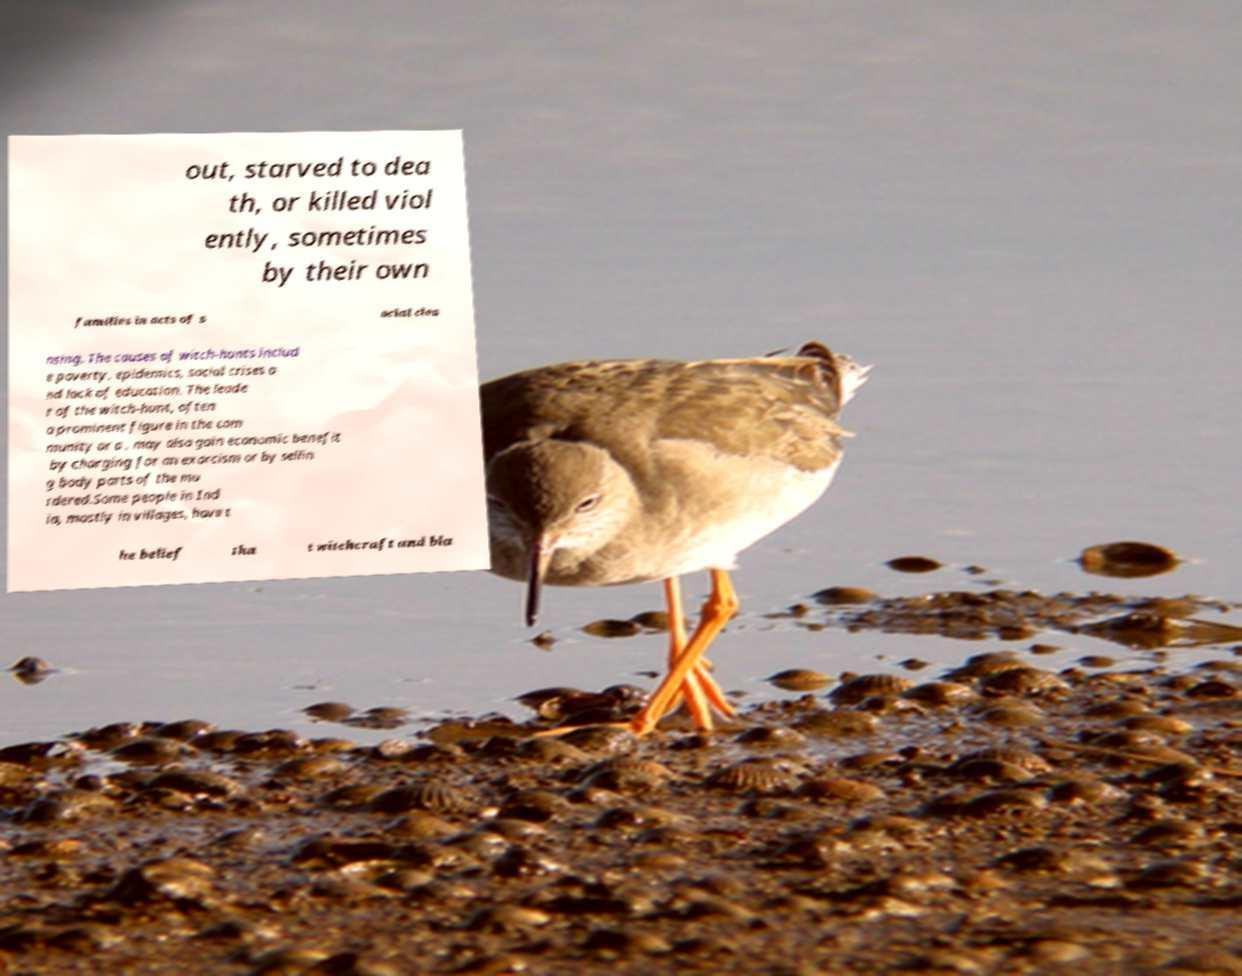Could you assist in decoding the text presented in this image and type it out clearly? out, starved to dea th, or killed viol ently, sometimes by their own families in acts of s ocial clea nsing. The causes of witch-hunts includ e poverty, epidemics, social crises a nd lack of education. The leade r of the witch-hunt, often a prominent figure in the com munity or a , may also gain economic benefit by charging for an exorcism or by sellin g body parts of the mu rdered.Some people in Ind ia, mostly in villages, have t he belief tha t witchcraft and bla 